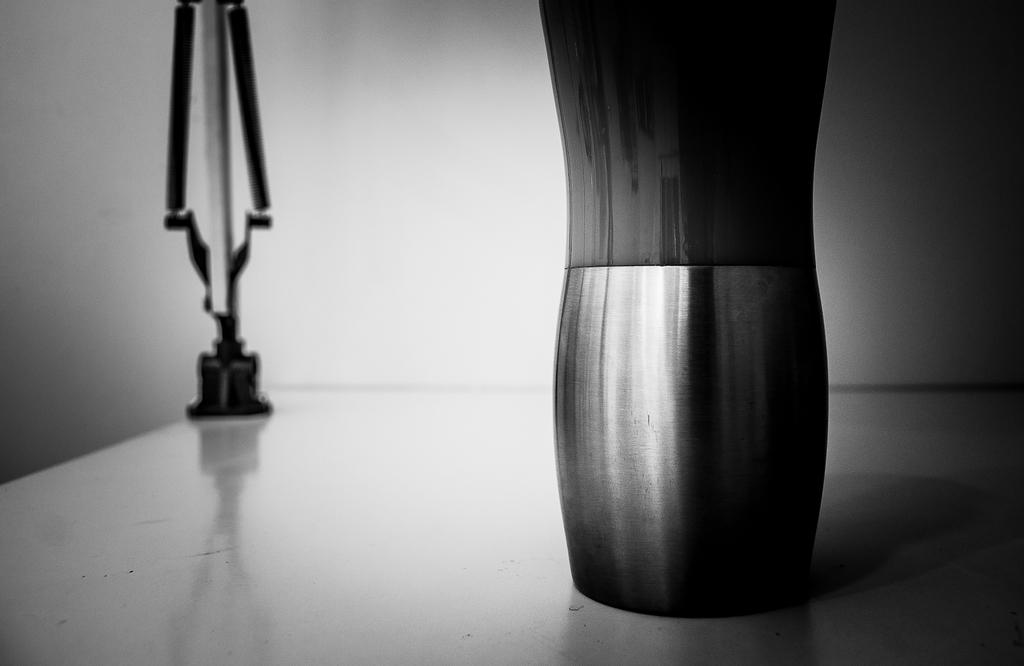What is the color scheme of the image? The image is black and white. What piece of furniture can be seen in the image? There is a table in the image. How many objects are on the table? There are two objects on the table. What is visible in the background of the image? There is a wall in the background of the image. What type of gold jewelry is the doll wearing in the image? There is no doll or gold jewelry present in the image. How many bikes are parked near the table in the image? There are no bikes present in the image. 